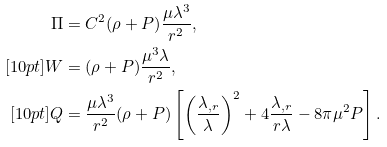<formula> <loc_0><loc_0><loc_500><loc_500>\Pi & = C ^ { 2 } ( \rho + P ) \frac { \mu \lambda ^ { 3 } } { r ^ { 2 } } , \\ [ 1 0 p t ] W & = ( \rho + P ) \frac { \mu ^ { 3 } \lambda } { r ^ { 2 } } , \\ [ 1 0 p t ] Q & = \frac { \mu \lambda ^ { 3 } } { r ^ { 2 } } ( \rho + P ) \left [ \left ( \frac { \lambda _ { , r } } { \lambda } \right ) ^ { 2 } + 4 \frac { \lambda _ { , r } } { r \lambda } - 8 \pi \mu ^ { 2 } P \right ] .</formula> 